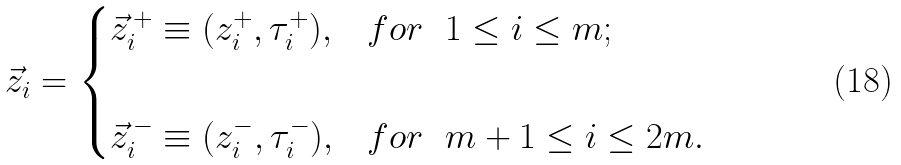<formula> <loc_0><loc_0><loc_500><loc_500>\vec { z } _ { i } = \begin{cases} \vec { z } _ { i } ^ { \, + } \equiv ( z _ { i } ^ { + } , \tau _ { i } ^ { + } ) , & f o r \ \ 1 \leq i \leq m ; \\ & \\ \vec { z } _ { i } ^ { \, - } \equiv ( z _ { i } ^ { - } , \tau _ { i } ^ { - } ) , & f o r \ \ m + 1 \leq i \leq 2 m . \end{cases}</formula> 